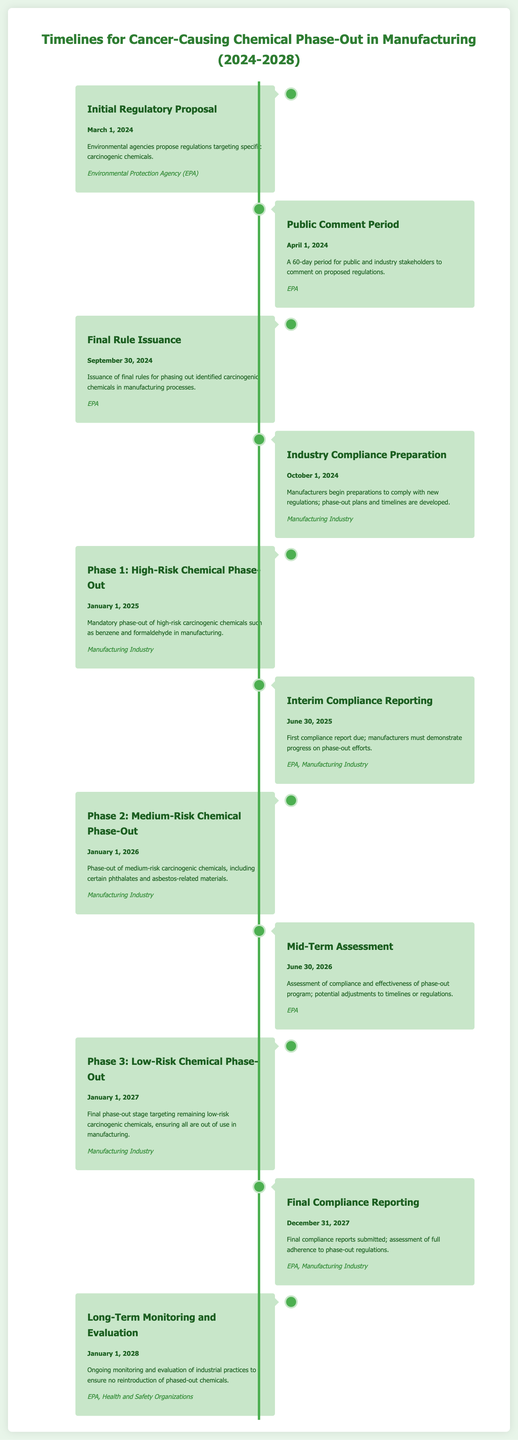What is the date for the Initial Regulatory Proposal? The Initial Regulatory Proposal is scheduled for March 1, 2024, according to the timeline.
Answer: March 1, 2024 How long is the Public Comment Period? The Public Comment Period lasts for 60 days, beginning on April 1, 2024.
Answer: 60 days Which chemicals are targeted in Phase 1? Phase 1 targets high-risk carcinogenic chemicals such as benzene and formaldehyde, as noted in the document.
Answer: benzene and formaldehyde When is the final compliance report due? The final compliance report is due on December 31, 2027, as specified in the timeline.
Answer: December 31, 2027 What organization issues the Final Rule? The Final Rule is issued by the Environmental Protection Agency (EPA), according to the timeline.
Answer: Environmental Protection Agency (EPA) What are the key chemicals phased out in Phase 2? Phase 2 involves the phase-out of medium-risk carcinogenic chemicals, including certain phthalates and asbestos-related materials.
Answer: certain phthalates and asbestos-related materials When does the Long-Term Monitoring and Evaluation start? Long-Term Monitoring and Evaluation begins on January 1, 2028, as shown in the timeline.
Answer: January 1, 2028 What is the purpose of the Mid-Term Assessment? The Mid-Term Assessment is aimed at evaluating compliance and the effectiveness of the phase-out program.
Answer: evaluating compliance and effectiveness Which entities are involved in the Final Compliance Reporting? The entities involved in Final Compliance Reporting are the EPA and the Manufacturing Industry.
Answer: EPA, Manufacturing Industry 